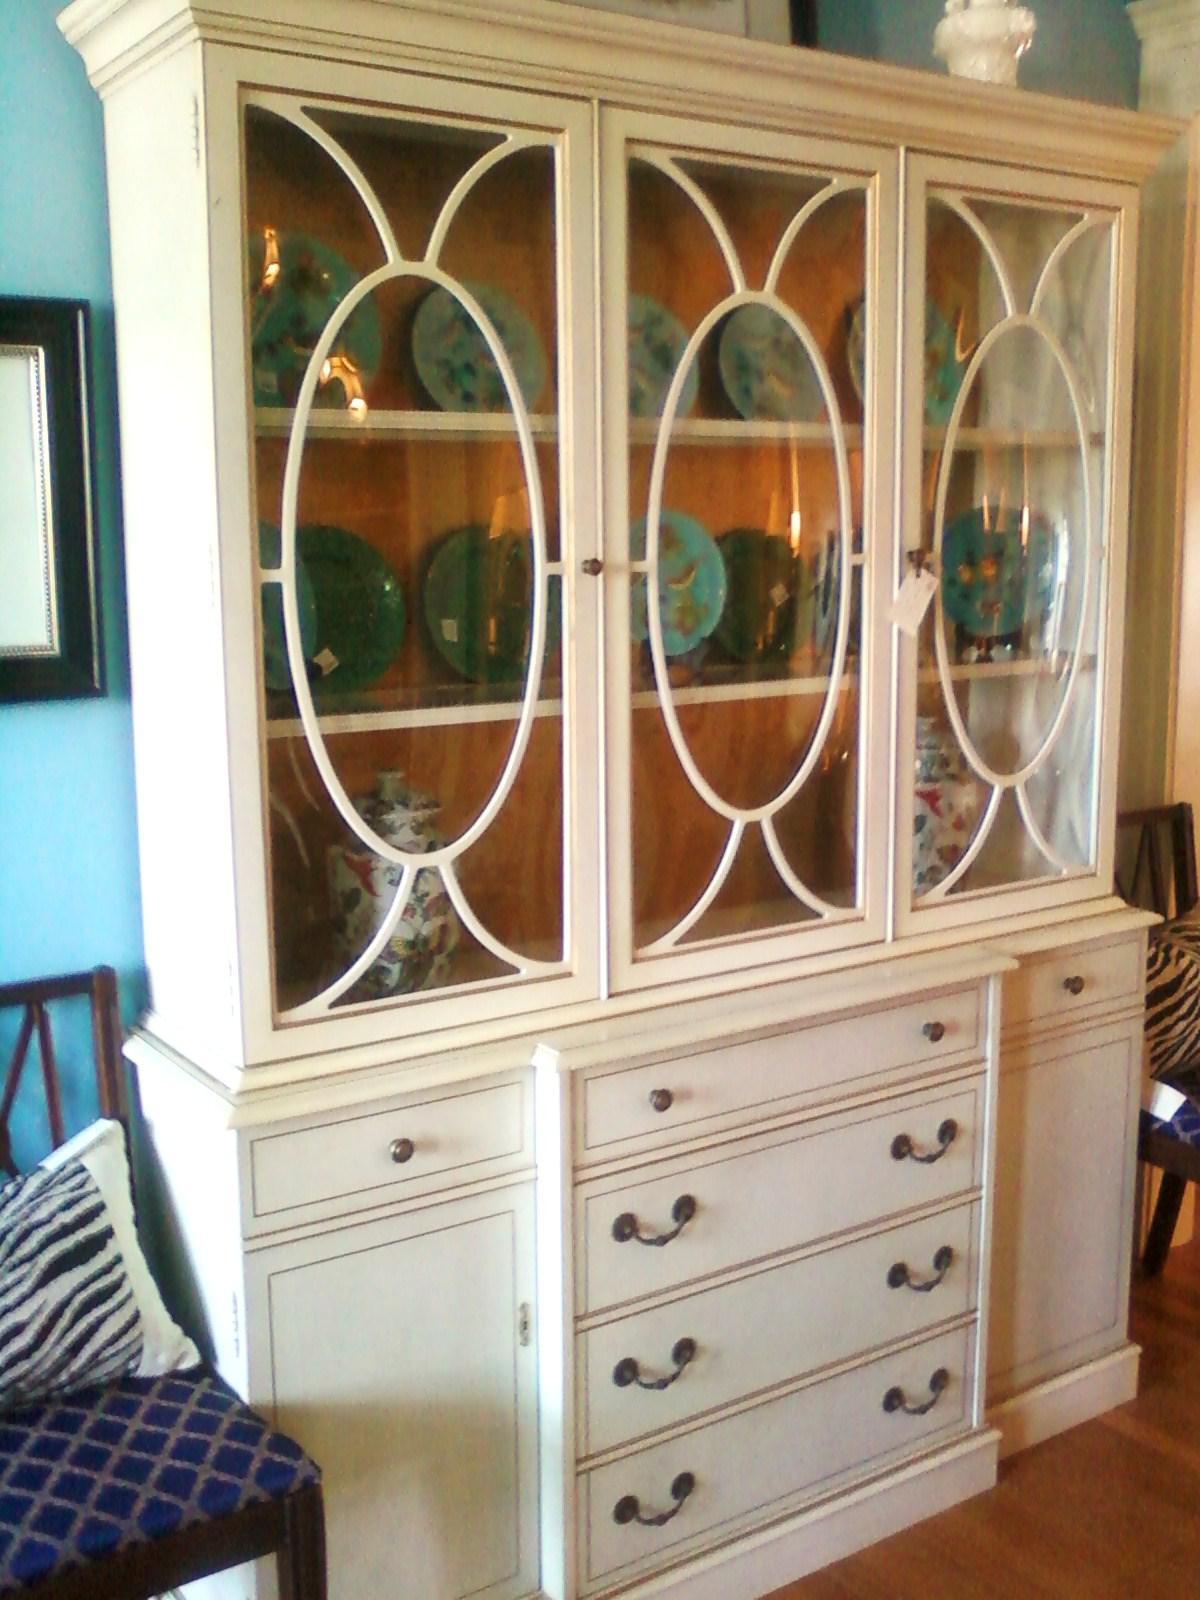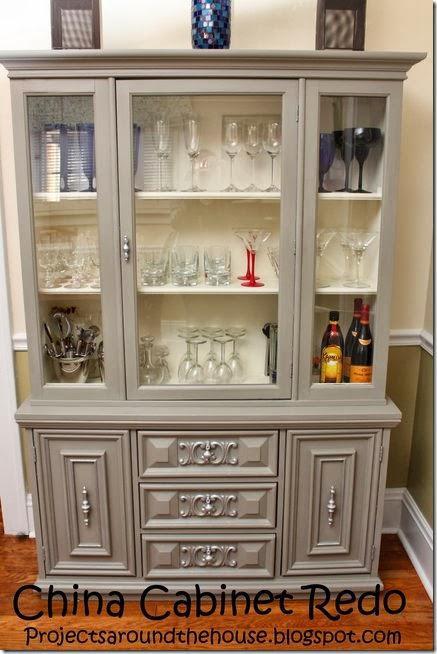The first image is the image on the left, the second image is the image on the right. For the images displayed, is the sentence "The inside of one of the cabinets is an aqua color." factually correct? Answer yes or no. No. The first image is the image on the left, the second image is the image on the right. For the images displayed, is the sentence "One cabinet has an open space with scrolled edges under the glass-front cabinets." factually correct? Answer yes or no. No. 